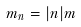Convert formula to latex. <formula><loc_0><loc_0><loc_500><loc_500>m _ { n } = | n | m</formula> 